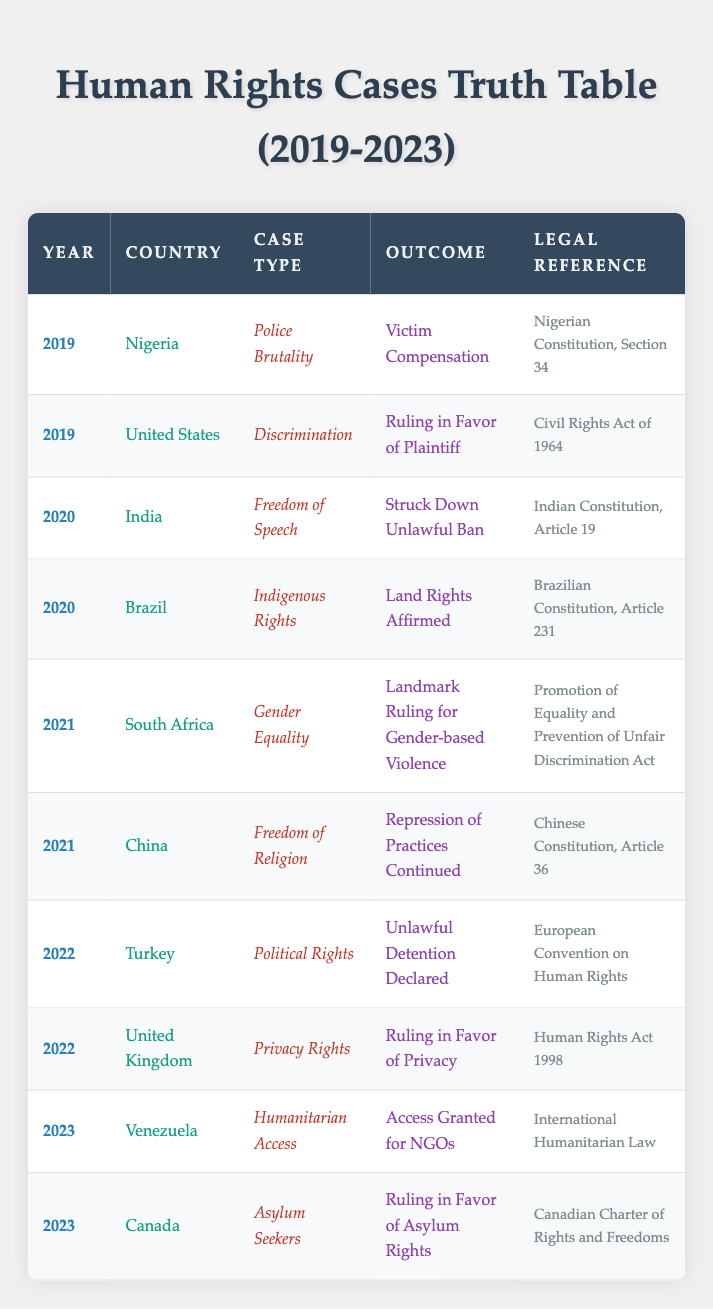What type of case did Nigeria handle in 2019? The table lists the specific case types by country and year. Looking at Nigeria in 2019, the case type is "Police Brutality."
Answer: Police Brutality Which country dealt with a case regarding discrimination in 2019? The table shows that the United States addressed a discrimination case in 2019.
Answer: United States How many total human rights cases are recorded in 2020? There are two distinct cases listed under the year 2020: one in India and one in Brazil.
Answer: 2 Was there a ruling in favor of asylum rights in any case from 2023? The table indicates that Canada ruled in favor of asylum rights in 2023; hence, the answer is yes.
Answer: Yes What was the outcome of the human rights case in Turkey in 2022? Referring to the table, Turkey's outcome for political rights cases in 2022 was "Unlawful Detention Declared."
Answer: Unlawful Detention Declared In how many years did cases related to police violence appear? The table only mentions police brutality in Nigeria in 2019, indicating this case type occurred in one year.
Answer: 1 Which country had a case related to freedom of religion in 2021, and what was the outcome? The table notes that China had a freedom of religion case in 2021, with the outcome being a continuation of the repression of practices.
Answer: China; Repression of Practices Continued What is the legal reference for the ruling in favor of privacy rights in the UK in 2022? The table cites the "Human Rights Act 1998" as the legal reference for the case related to privacy rights in the UK in 2022.
Answer: Human Rights Act 1998 Which country was involved in a humanitarian access case in 2023, and what was the outcome? According to the table, Venezuela was the country handling humanitarian access in 2023, with the outcome being "Access Granted for NGOs."
Answer: Venezuela; Access Granted for NGOs 